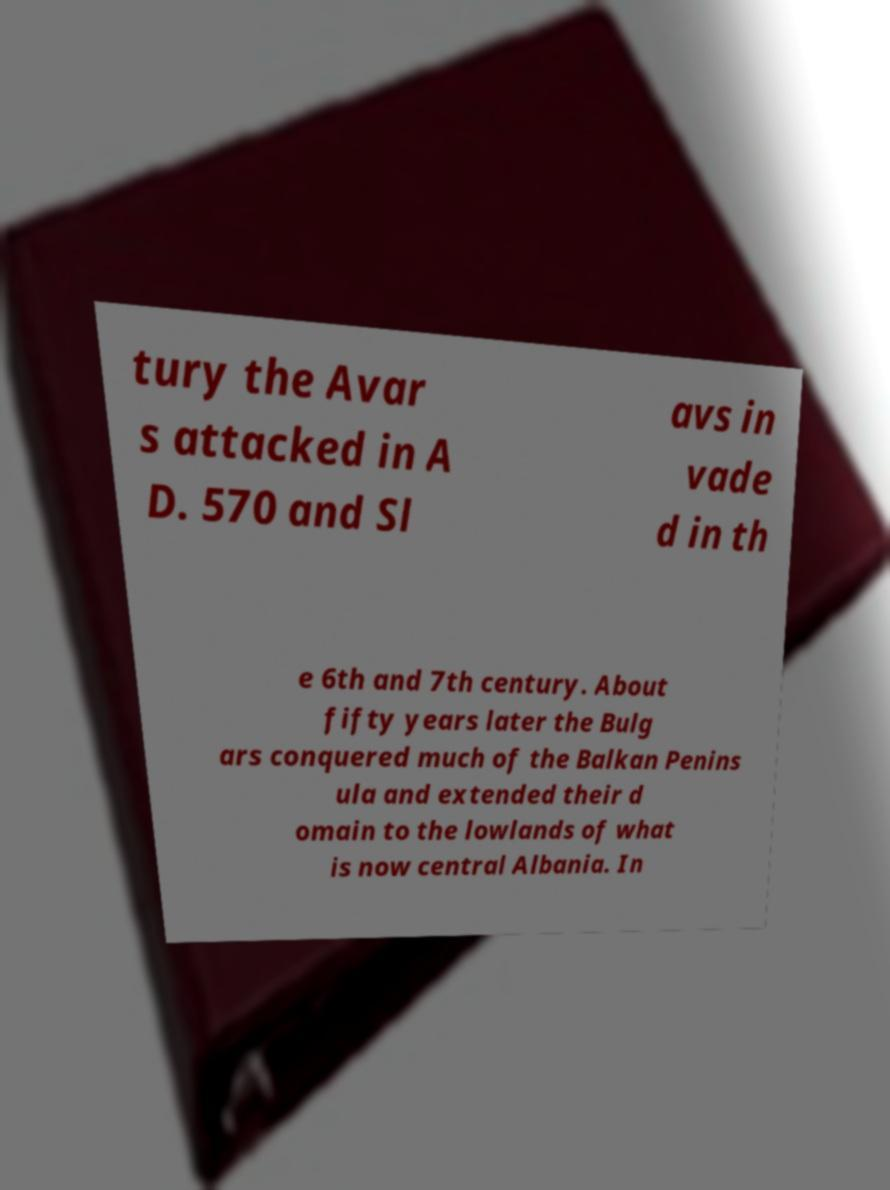Could you extract and type out the text from this image? tury the Avar s attacked in A D. 570 and Sl avs in vade d in th e 6th and 7th century. About fifty years later the Bulg ars conquered much of the Balkan Penins ula and extended their d omain to the lowlands of what is now central Albania. In 